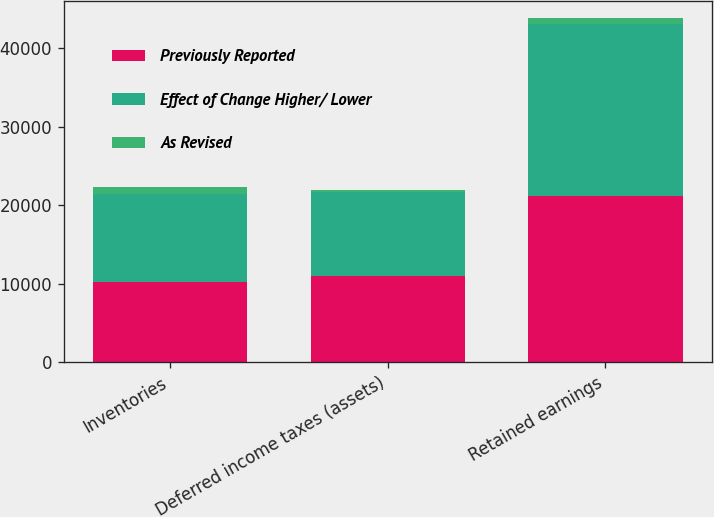Convert chart to OTSL. <chart><loc_0><loc_0><loc_500><loc_500><stacked_bar_chart><ecel><fcel>Inventories<fcel>Deferred income taxes (assets)<fcel>Retained earnings<nl><fcel>Previously Reported<fcel>10277<fcel>10973<fcel>21218<nl><fcel>Effect of Change Higher/ Lower<fcel>11176<fcel>10762<fcel>21906<nl><fcel>As Revised<fcel>899<fcel>211<fcel>688<nl></chart> 